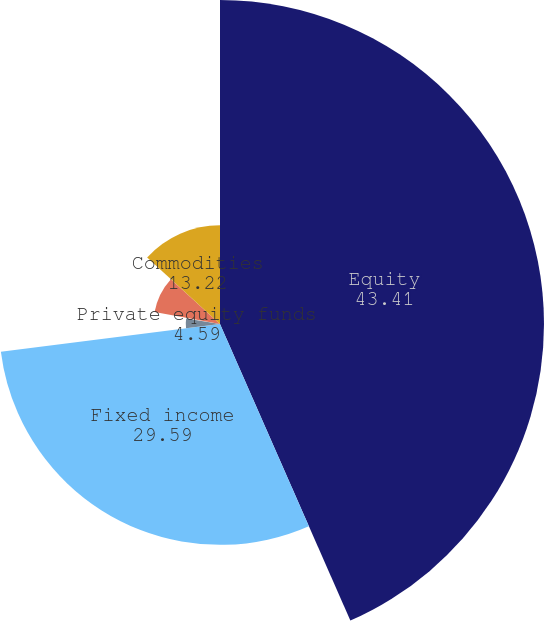Convert chart. <chart><loc_0><loc_0><loc_500><loc_500><pie_chart><fcel>Equity<fcel>Fixed income<fcel>Private equity funds<fcel>Real estate funds<fcel>Hedge funds<fcel>Commodities<nl><fcel>43.41%<fcel>29.59%<fcel>4.59%<fcel>0.28%<fcel>8.91%<fcel>13.22%<nl></chart> 